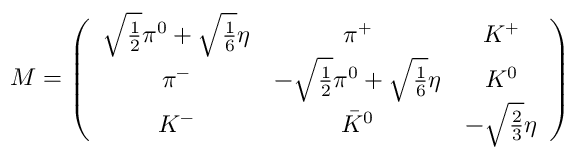<formula> <loc_0><loc_0><loc_500><loc_500>{ M } = \left ( \begin{array} { c c c } { { \sqrt { \frac { 1 } { 2 } } \pi ^ { 0 } + \sqrt { \frac { 1 } { 6 } } \eta } } & { { \pi ^ { + } } } & { { K ^ { + } } } \\ { { \pi ^ { - } } } & { { - \sqrt { \frac { 1 } { 2 } } \pi ^ { 0 } + \sqrt { \frac { 1 } { 6 } } \eta } } & { { K ^ { 0 } } } \\ { { K ^ { - } } } & { { { \bar { K } } ^ { 0 } } } & { { - \sqrt { \frac { 2 } { 3 } } \eta } } \end{array} \right )</formula> 